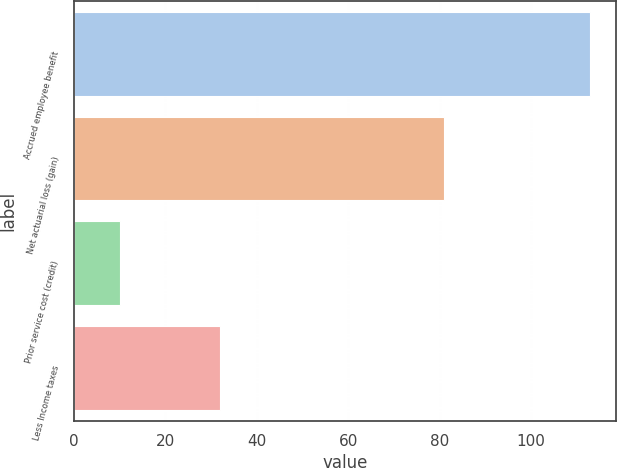<chart> <loc_0><loc_0><loc_500><loc_500><bar_chart><fcel>Accrued employee benefit<fcel>Net actuarial loss (gain)<fcel>Prior service cost (credit)<fcel>Less Income taxes<nl><fcel>113<fcel>81<fcel>10<fcel>32<nl></chart> 